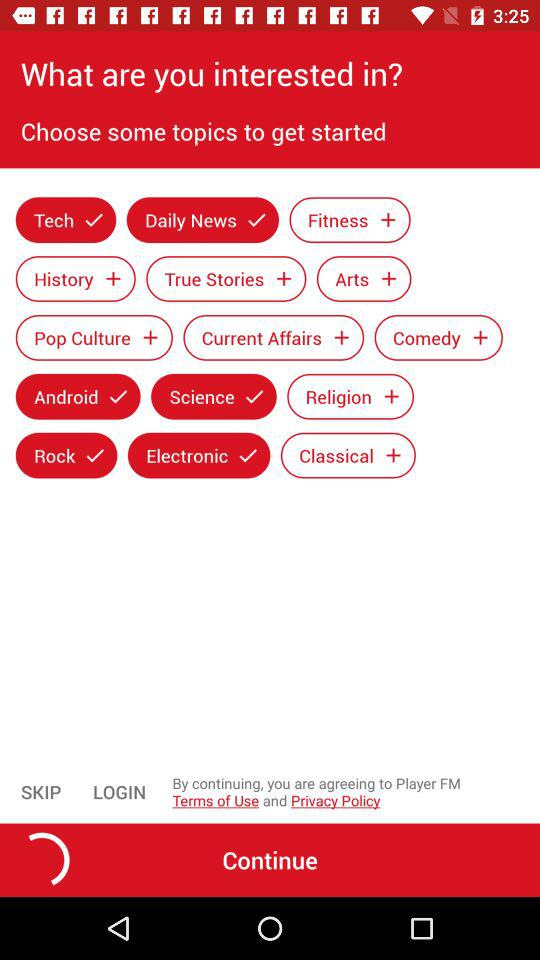Which are the selected topics? The selected topics are: "Tech", "Daily News", "Android", "Science", "Rock", and "Electronic". 